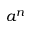<formula> <loc_0><loc_0><loc_500><loc_500>a ^ { n }</formula> 